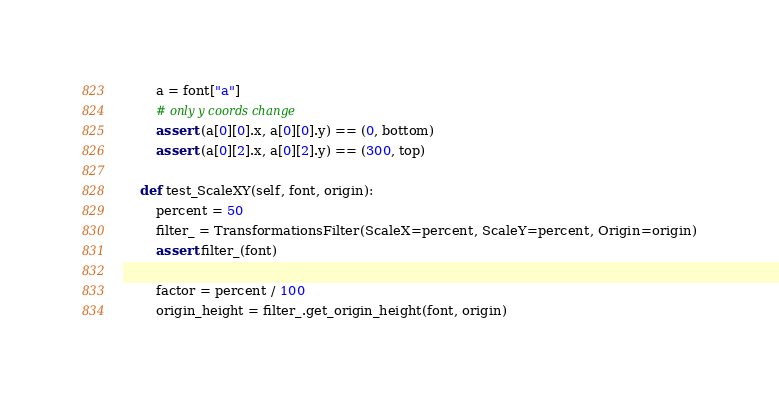Convert code to text. <code><loc_0><loc_0><loc_500><loc_500><_Python_>        a = font["a"]
        # only y coords change
        assert (a[0][0].x, a[0][0].y) == (0, bottom)
        assert (a[0][2].x, a[0][2].y) == (300, top)

    def test_ScaleXY(self, font, origin):
        percent = 50
        filter_ = TransformationsFilter(ScaleX=percent, ScaleY=percent, Origin=origin)
        assert filter_(font)

        factor = percent / 100
        origin_height = filter_.get_origin_height(font, origin)</code> 